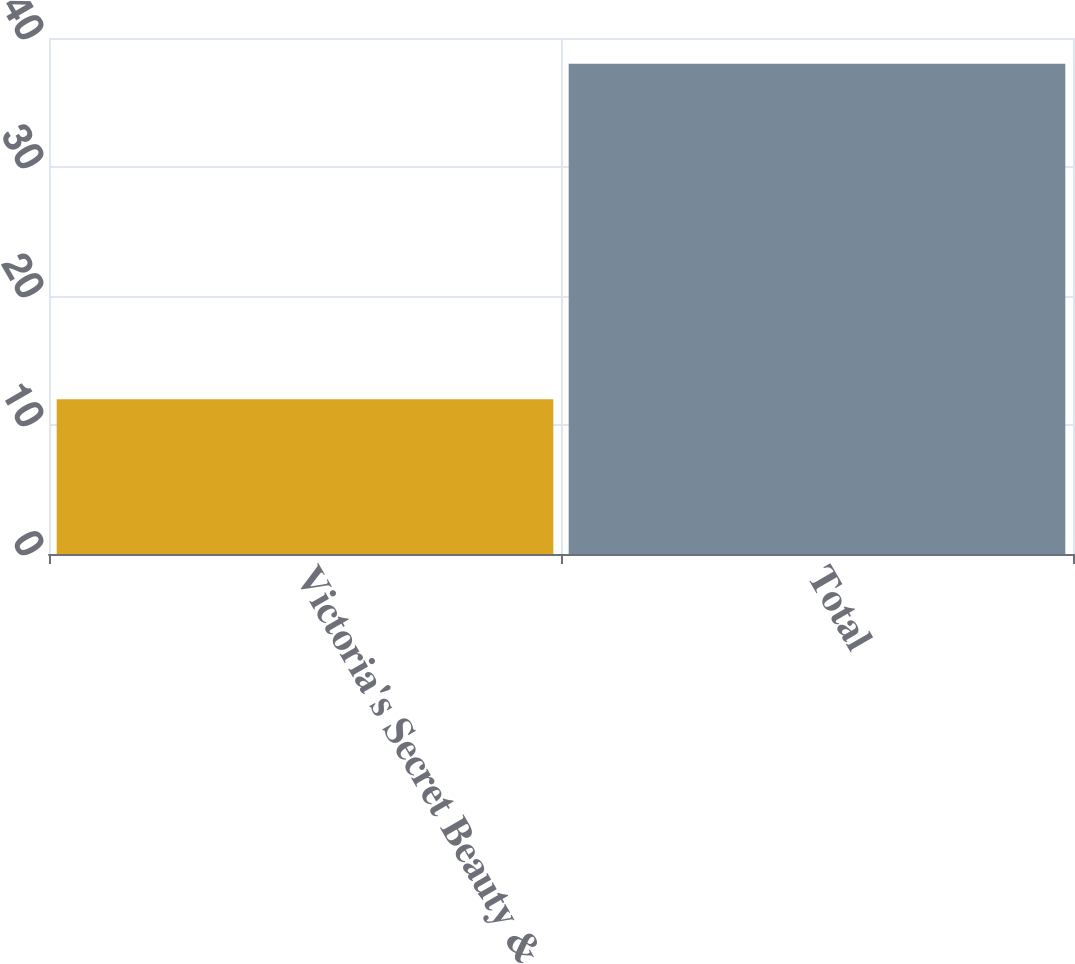Convert chart. <chart><loc_0><loc_0><loc_500><loc_500><bar_chart><fcel>Victoria's Secret Beauty &<fcel>Total<nl><fcel>12<fcel>38<nl></chart> 